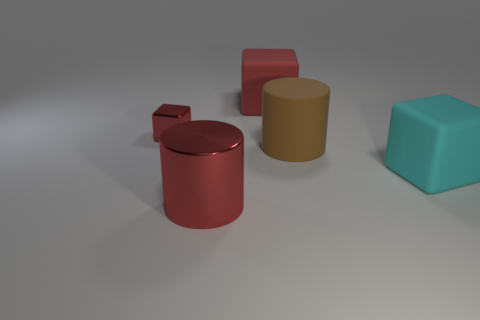Add 1 blue matte spheres. How many objects exist? 6 Subtract all cylinders. How many objects are left? 3 Subtract all brown spheres. Subtract all big red rubber things. How many objects are left? 4 Add 5 big red things. How many big red things are left? 7 Add 5 cyan rubber cubes. How many cyan rubber cubes exist? 6 Subtract 0 brown blocks. How many objects are left? 5 